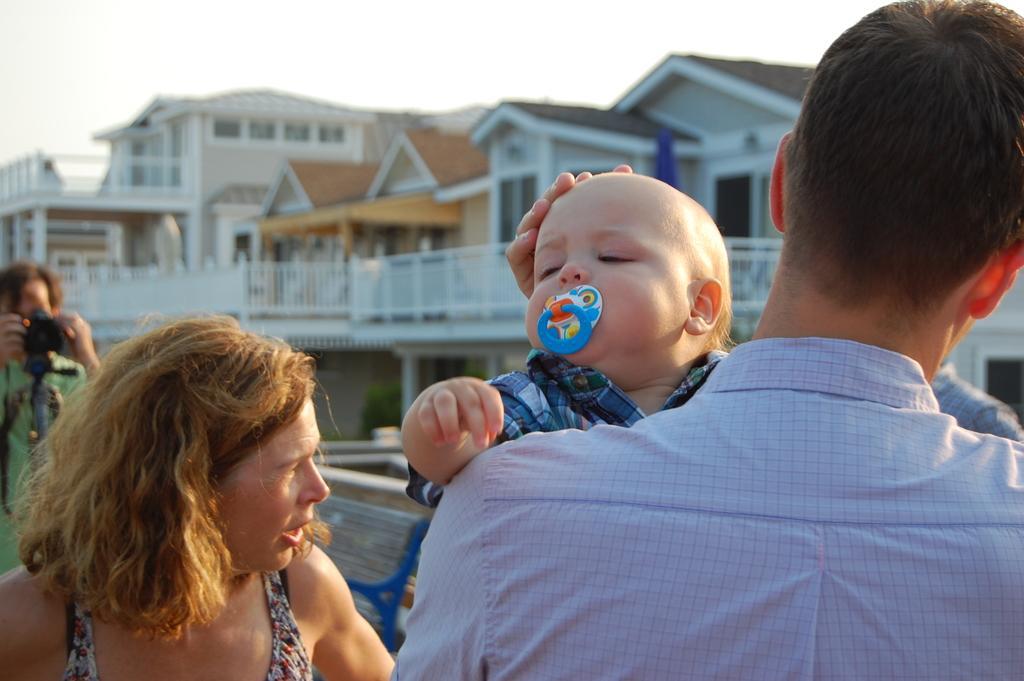Describe this image in one or two sentences. This picture is clicked outside, and in the foreground we can see the group of people. On the right there is a person carrying a baby and seems to be standing. In the background we can see the sky, buildings, green leaves and a bench. In the left corner there is a person holding a camera, standing and seems to be clicking pictures. 